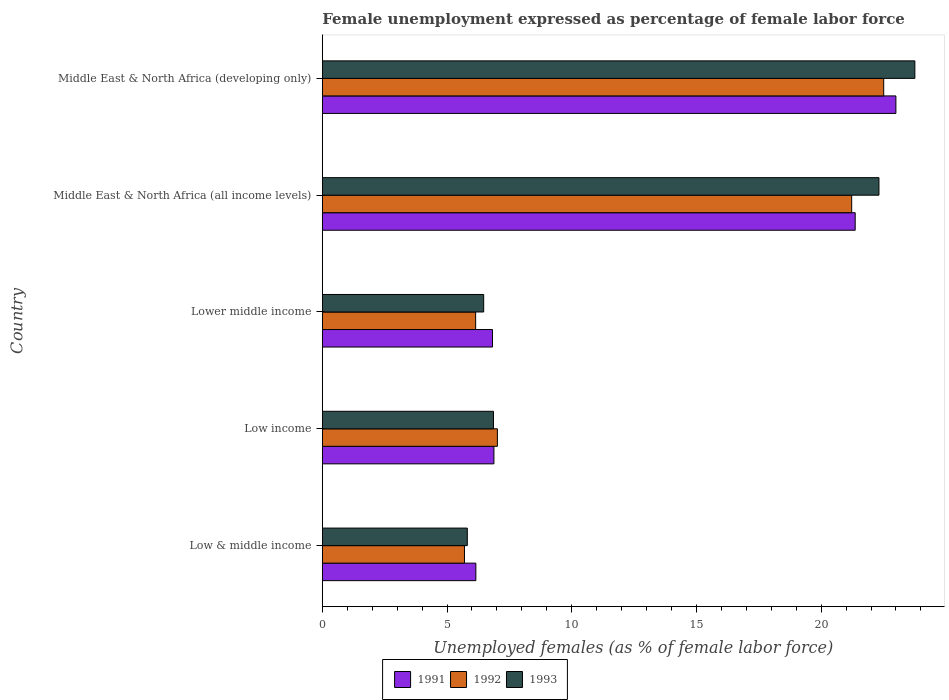How many different coloured bars are there?
Your answer should be very brief. 3. How many groups of bars are there?
Keep it short and to the point. 5. How many bars are there on the 1st tick from the top?
Your response must be concise. 3. How many bars are there on the 2nd tick from the bottom?
Give a very brief answer. 3. What is the label of the 3rd group of bars from the top?
Keep it short and to the point. Lower middle income. In how many cases, is the number of bars for a given country not equal to the number of legend labels?
Give a very brief answer. 0. What is the unemployment in females in in 1993 in Low & middle income?
Give a very brief answer. 5.81. Across all countries, what is the maximum unemployment in females in in 1993?
Make the answer very short. 23.76. Across all countries, what is the minimum unemployment in females in in 1992?
Your response must be concise. 5.7. In which country was the unemployment in females in in 1991 maximum?
Provide a succinct answer. Middle East & North Africa (developing only). What is the total unemployment in females in in 1991 in the graph?
Keep it short and to the point. 64.22. What is the difference between the unemployment in females in in 1992 in Lower middle income and that in Middle East & North Africa (all income levels)?
Offer a terse response. -15.08. What is the difference between the unemployment in females in in 1992 in Low & middle income and the unemployment in females in in 1991 in Low income?
Make the answer very short. -1.18. What is the average unemployment in females in in 1991 per country?
Keep it short and to the point. 12.84. What is the difference between the unemployment in females in in 1992 and unemployment in females in in 1993 in Middle East & North Africa (all income levels)?
Your response must be concise. -1.09. What is the ratio of the unemployment in females in in 1992 in Low & middle income to that in Middle East & North Africa (developing only)?
Make the answer very short. 0.25. Is the unemployment in females in in 1993 in Middle East & North Africa (all income levels) less than that in Middle East & North Africa (developing only)?
Make the answer very short. Yes. What is the difference between the highest and the second highest unemployment in females in in 1993?
Make the answer very short. 1.44. What is the difference between the highest and the lowest unemployment in females in in 1993?
Your answer should be very brief. 17.94. In how many countries, is the unemployment in females in in 1993 greater than the average unemployment in females in in 1993 taken over all countries?
Offer a very short reply. 2. What does the 2nd bar from the top in Low & middle income represents?
Offer a very short reply. 1992. How many bars are there?
Give a very brief answer. 15. How many countries are there in the graph?
Keep it short and to the point. 5. Are the values on the major ticks of X-axis written in scientific E-notation?
Give a very brief answer. No. Does the graph contain any zero values?
Offer a terse response. No. How many legend labels are there?
Keep it short and to the point. 3. How are the legend labels stacked?
Offer a very short reply. Horizontal. What is the title of the graph?
Make the answer very short. Female unemployment expressed as percentage of female labor force. Does "2009" appear as one of the legend labels in the graph?
Offer a very short reply. No. What is the label or title of the X-axis?
Offer a very short reply. Unemployed females (as % of female labor force). What is the Unemployed females (as % of female labor force) in 1991 in Low & middle income?
Give a very brief answer. 6.16. What is the Unemployed females (as % of female labor force) of 1992 in Low & middle income?
Give a very brief answer. 5.7. What is the Unemployed females (as % of female labor force) of 1993 in Low & middle income?
Provide a short and direct response. 5.81. What is the Unemployed females (as % of female labor force) in 1991 in Low income?
Give a very brief answer. 6.88. What is the Unemployed females (as % of female labor force) of 1992 in Low income?
Provide a succinct answer. 7.02. What is the Unemployed females (as % of female labor force) in 1993 in Low income?
Your answer should be very brief. 6.86. What is the Unemployed females (as % of female labor force) in 1991 in Lower middle income?
Provide a succinct answer. 6.82. What is the Unemployed females (as % of female labor force) in 1992 in Lower middle income?
Ensure brevity in your answer.  6.15. What is the Unemployed females (as % of female labor force) in 1993 in Lower middle income?
Keep it short and to the point. 6.47. What is the Unemployed females (as % of female labor force) in 1991 in Middle East & North Africa (all income levels)?
Provide a short and direct response. 21.36. What is the Unemployed females (as % of female labor force) in 1992 in Middle East & North Africa (all income levels)?
Offer a terse response. 21.22. What is the Unemployed females (as % of female labor force) in 1993 in Middle East & North Africa (all income levels)?
Make the answer very short. 22.32. What is the Unemployed females (as % of female labor force) in 1991 in Middle East & North Africa (developing only)?
Provide a short and direct response. 23. What is the Unemployed females (as % of female labor force) of 1992 in Middle East & North Africa (developing only)?
Your answer should be very brief. 22.51. What is the Unemployed females (as % of female labor force) in 1993 in Middle East & North Africa (developing only)?
Offer a terse response. 23.76. Across all countries, what is the maximum Unemployed females (as % of female labor force) in 1991?
Give a very brief answer. 23. Across all countries, what is the maximum Unemployed females (as % of female labor force) of 1992?
Your response must be concise. 22.51. Across all countries, what is the maximum Unemployed females (as % of female labor force) of 1993?
Your answer should be very brief. 23.76. Across all countries, what is the minimum Unemployed females (as % of female labor force) of 1991?
Provide a succinct answer. 6.16. Across all countries, what is the minimum Unemployed females (as % of female labor force) in 1992?
Your response must be concise. 5.7. Across all countries, what is the minimum Unemployed females (as % of female labor force) in 1993?
Keep it short and to the point. 5.81. What is the total Unemployed females (as % of female labor force) of 1991 in the graph?
Your response must be concise. 64.22. What is the total Unemployed females (as % of female labor force) in 1992 in the graph?
Give a very brief answer. 62.6. What is the total Unemployed females (as % of female labor force) in 1993 in the graph?
Offer a terse response. 65.22. What is the difference between the Unemployed females (as % of female labor force) in 1991 in Low & middle income and that in Low income?
Offer a very short reply. -0.72. What is the difference between the Unemployed females (as % of female labor force) in 1992 in Low & middle income and that in Low income?
Make the answer very short. -1.32. What is the difference between the Unemployed females (as % of female labor force) of 1993 in Low & middle income and that in Low income?
Keep it short and to the point. -1.05. What is the difference between the Unemployed females (as % of female labor force) in 1991 in Low & middle income and that in Lower middle income?
Provide a succinct answer. -0.67. What is the difference between the Unemployed females (as % of female labor force) of 1992 in Low & middle income and that in Lower middle income?
Your answer should be compact. -0.45. What is the difference between the Unemployed females (as % of female labor force) of 1993 in Low & middle income and that in Lower middle income?
Ensure brevity in your answer.  -0.66. What is the difference between the Unemployed females (as % of female labor force) of 1991 in Low & middle income and that in Middle East & North Africa (all income levels)?
Your answer should be very brief. -15.21. What is the difference between the Unemployed females (as % of female labor force) in 1992 in Low & middle income and that in Middle East & North Africa (all income levels)?
Ensure brevity in your answer.  -15.52. What is the difference between the Unemployed females (as % of female labor force) of 1993 in Low & middle income and that in Middle East & North Africa (all income levels)?
Your answer should be very brief. -16.5. What is the difference between the Unemployed females (as % of female labor force) of 1991 in Low & middle income and that in Middle East & North Africa (developing only)?
Offer a very short reply. -16.84. What is the difference between the Unemployed females (as % of female labor force) of 1992 in Low & middle income and that in Middle East & North Africa (developing only)?
Provide a short and direct response. -16.81. What is the difference between the Unemployed females (as % of female labor force) of 1993 in Low & middle income and that in Middle East & North Africa (developing only)?
Your answer should be very brief. -17.94. What is the difference between the Unemployed females (as % of female labor force) of 1991 in Low income and that in Lower middle income?
Provide a succinct answer. 0.06. What is the difference between the Unemployed females (as % of female labor force) of 1992 in Low income and that in Lower middle income?
Your answer should be very brief. 0.87. What is the difference between the Unemployed females (as % of female labor force) in 1993 in Low income and that in Lower middle income?
Offer a terse response. 0.39. What is the difference between the Unemployed females (as % of female labor force) in 1991 in Low income and that in Middle East & North Africa (all income levels)?
Provide a succinct answer. -14.48. What is the difference between the Unemployed females (as % of female labor force) in 1992 in Low income and that in Middle East & North Africa (all income levels)?
Keep it short and to the point. -14.2. What is the difference between the Unemployed females (as % of female labor force) of 1993 in Low income and that in Middle East & North Africa (all income levels)?
Your response must be concise. -15.45. What is the difference between the Unemployed females (as % of female labor force) of 1991 in Low income and that in Middle East & North Africa (developing only)?
Make the answer very short. -16.12. What is the difference between the Unemployed females (as % of female labor force) of 1992 in Low income and that in Middle East & North Africa (developing only)?
Ensure brevity in your answer.  -15.49. What is the difference between the Unemployed females (as % of female labor force) of 1993 in Low income and that in Middle East & North Africa (developing only)?
Make the answer very short. -16.89. What is the difference between the Unemployed females (as % of female labor force) of 1991 in Lower middle income and that in Middle East & North Africa (all income levels)?
Give a very brief answer. -14.54. What is the difference between the Unemployed females (as % of female labor force) of 1992 in Lower middle income and that in Middle East & North Africa (all income levels)?
Offer a terse response. -15.08. What is the difference between the Unemployed females (as % of female labor force) of 1993 in Lower middle income and that in Middle East & North Africa (all income levels)?
Offer a terse response. -15.85. What is the difference between the Unemployed females (as % of female labor force) in 1991 in Lower middle income and that in Middle East & North Africa (developing only)?
Ensure brevity in your answer.  -16.17. What is the difference between the Unemployed females (as % of female labor force) of 1992 in Lower middle income and that in Middle East & North Africa (developing only)?
Offer a terse response. -16.36. What is the difference between the Unemployed females (as % of female labor force) of 1993 in Lower middle income and that in Middle East & North Africa (developing only)?
Ensure brevity in your answer.  -17.29. What is the difference between the Unemployed females (as % of female labor force) in 1991 in Middle East & North Africa (all income levels) and that in Middle East & North Africa (developing only)?
Keep it short and to the point. -1.63. What is the difference between the Unemployed females (as % of female labor force) of 1992 in Middle East & North Africa (all income levels) and that in Middle East & North Africa (developing only)?
Give a very brief answer. -1.28. What is the difference between the Unemployed females (as % of female labor force) of 1993 in Middle East & North Africa (all income levels) and that in Middle East & North Africa (developing only)?
Ensure brevity in your answer.  -1.44. What is the difference between the Unemployed females (as % of female labor force) in 1991 in Low & middle income and the Unemployed females (as % of female labor force) in 1992 in Low income?
Give a very brief answer. -0.86. What is the difference between the Unemployed females (as % of female labor force) of 1991 in Low & middle income and the Unemployed females (as % of female labor force) of 1993 in Low income?
Provide a succinct answer. -0.71. What is the difference between the Unemployed females (as % of female labor force) in 1992 in Low & middle income and the Unemployed females (as % of female labor force) in 1993 in Low income?
Provide a succinct answer. -1.16. What is the difference between the Unemployed females (as % of female labor force) of 1991 in Low & middle income and the Unemployed females (as % of female labor force) of 1992 in Lower middle income?
Offer a very short reply. 0.01. What is the difference between the Unemployed females (as % of female labor force) of 1991 in Low & middle income and the Unemployed females (as % of female labor force) of 1993 in Lower middle income?
Your answer should be very brief. -0.31. What is the difference between the Unemployed females (as % of female labor force) in 1992 in Low & middle income and the Unemployed females (as % of female labor force) in 1993 in Lower middle income?
Offer a very short reply. -0.77. What is the difference between the Unemployed females (as % of female labor force) of 1991 in Low & middle income and the Unemployed females (as % of female labor force) of 1992 in Middle East & North Africa (all income levels)?
Your response must be concise. -15.07. What is the difference between the Unemployed females (as % of female labor force) of 1991 in Low & middle income and the Unemployed females (as % of female labor force) of 1993 in Middle East & North Africa (all income levels)?
Ensure brevity in your answer.  -16.16. What is the difference between the Unemployed females (as % of female labor force) of 1992 in Low & middle income and the Unemployed females (as % of female labor force) of 1993 in Middle East & North Africa (all income levels)?
Give a very brief answer. -16.62. What is the difference between the Unemployed females (as % of female labor force) in 1991 in Low & middle income and the Unemployed females (as % of female labor force) in 1992 in Middle East & North Africa (developing only)?
Your answer should be compact. -16.35. What is the difference between the Unemployed females (as % of female labor force) of 1991 in Low & middle income and the Unemployed females (as % of female labor force) of 1993 in Middle East & North Africa (developing only)?
Your response must be concise. -17.6. What is the difference between the Unemployed females (as % of female labor force) in 1992 in Low & middle income and the Unemployed females (as % of female labor force) in 1993 in Middle East & North Africa (developing only)?
Make the answer very short. -18.06. What is the difference between the Unemployed females (as % of female labor force) in 1991 in Low income and the Unemployed females (as % of female labor force) in 1992 in Lower middle income?
Your response must be concise. 0.73. What is the difference between the Unemployed females (as % of female labor force) of 1991 in Low income and the Unemployed females (as % of female labor force) of 1993 in Lower middle income?
Your answer should be compact. 0.41. What is the difference between the Unemployed females (as % of female labor force) in 1992 in Low income and the Unemployed females (as % of female labor force) in 1993 in Lower middle income?
Offer a terse response. 0.55. What is the difference between the Unemployed females (as % of female labor force) in 1991 in Low income and the Unemployed females (as % of female labor force) in 1992 in Middle East & North Africa (all income levels)?
Make the answer very short. -14.34. What is the difference between the Unemployed females (as % of female labor force) of 1991 in Low income and the Unemployed females (as % of female labor force) of 1993 in Middle East & North Africa (all income levels)?
Ensure brevity in your answer.  -15.44. What is the difference between the Unemployed females (as % of female labor force) of 1992 in Low income and the Unemployed females (as % of female labor force) of 1993 in Middle East & North Africa (all income levels)?
Ensure brevity in your answer.  -15.3. What is the difference between the Unemployed females (as % of female labor force) in 1991 in Low income and the Unemployed females (as % of female labor force) in 1992 in Middle East & North Africa (developing only)?
Provide a succinct answer. -15.63. What is the difference between the Unemployed females (as % of female labor force) in 1991 in Low income and the Unemployed females (as % of female labor force) in 1993 in Middle East & North Africa (developing only)?
Give a very brief answer. -16.88. What is the difference between the Unemployed females (as % of female labor force) of 1992 in Low income and the Unemployed females (as % of female labor force) of 1993 in Middle East & North Africa (developing only)?
Give a very brief answer. -16.74. What is the difference between the Unemployed females (as % of female labor force) in 1991 in Lower middle income and the Unemployed females (as % of female labor force) in 1992 in Middle East & North Africa (all income levels)?
Offer a very short reply. -14.4. What is the difference between the Unemployed females (as % of female labor force) in 1991 in Lower middle income and the Unemployed females (as % of female labor force) in 1993 in Middle East & North Africa (all income levels)?
Keep it short and to the point. -15.49. What is the difference between the Unemployed females (as % of female labor force) in 1992 in Lower middle income and the Unemployed females (as % of female labor force) in 1993 in Middle East & North Africa (all income levels)?
Give a very brief answer. -16.17. What is the difference between the Unemployed females (as % of female labor force) in 1991 in Lower middle income and the Unemployed females (as % of female labor force) in 1992 in Middle East & North Africa (developing only)?
Provide a succinct answer. -15.69. What is the difference between the Unemployed females (as % of female labor force) in 1991 in Lower middle income and the Unemployed females (as % of female labor force) in 1993 in Middle East & North Africa (developing only)?
Keep it short and to the point. -16.93. What is the difference between the Unemployed females (as % of female labor force) of 1992 in Lower middle income and the Unemployed females (as % of female labor force) of 1993 in Middle East & North Africa (developing only)?
Offer a very short reply. -17.61. What is the difference between the Unemployed females (as % of female labor force) of 1991 in Middle East & North Africa (all income levels) and the Unemployed females (as % of female labor force) of 1992 in Middle East & North Africa (developing only)?
Provide a succinct answer. -1.14. What is the difference between the Unemployed females (as % of female labor force) of 1991 in Middle East & North Africa (all income levels) and the Unemployed females (as % of female labor force) of 1993 in Middle East & North Africa (developing only)?
Your answer should be very brief. -2.39. What is the difference between the Unemployed females (as % of female labor force) of 1992 in Middle East & North Africa (all income levels) and the Unemployed females (as % of female labor force) of 1993 in Middle East & North Africa (developing only)?
Your response must be concise. -2.53. What is the average Unemployed females (as % of female labor force) in 1991 per country?
Your answer should be very brief. 12.84. What is the average Unemployed females (as % of female labor force) of 1992 per country?
Offer a very short reply. 12.52. What is the average Unemployed females (as % of female labor force) of 1993 per country?
Offer a very short reply. 13.04. What is the difference between the Unemployed females (as % of female labor force) in 1991 and Unemployed females (as % of female labor force) in 1992 in Low & middle income?
Your response must be concise. 0.46. What is the difference between the Unemployed females (as % of female labor force) in 1991 and Unemployed females (as % of female labor force) in 1993 in Low & middle income?
Give a very brief answer. 0.34. What is the difference between the Unemployed females (as % of female labor force) in 1992 and Unemployed females (as % of female labor force) in 1993 in Low & middle income?
Your answer should be very brief. -0.11. What is the difference between the Unemployed females (as % of female labor force) in 1991 and Unemployed females (as % of female labor force) in 1992 in Low income?
Ensure brevity in your answer.  -0.14. What is the difference between the Unemployed females (as % of female labor force) of 1991 and Unemployed females (as % of female labor force) of 1993 in Low income?
Ensure brevity in your answer.  0.02. What is the difference between the Unemployed females (as % of female labor force) in 1992 and Unemployed females (as % of female labor force) in 1993 in Low income?
Keep it short and to the point. 0.16. What is the difference between the Unemployed females (as % of female labor force) of 1991 and Unemployed females (as % of female labor force) of 1992 in Lower middle income?
Keep it short and to the point. 0.68. What is the difference between the Unemployed females (as % of female labor force) of 1991 and Unemployed females (as % of female labor force) of 1993 in Lower middle income?
Provide a short and direct response. 0.35. What is the difference between the Unemployed females (as % of female labor force) in 1992 and Unemployed females (as % of female labor force) in 1993 in Lower middle income?
Provide a succinct answer. -0.32. What is the difference between the Unemployed females (as % of female labor force) in 1991 and Unemployed females (as % of female labor force) in 1992 in Middle East & North Africa (all income levels)?
Provide a short and direct response. 0.14. What is the difference between the Unemployed females (as % of female labor force) in 1991 and Unemployed females (as % of female labor force) in 1993 in Middle East & North Africa (all income levels)?
Your answer should be very brief. -0.95. What is the difference between the Unemployed females (as % of female labor force) of 1992 and Unemployed females (as % of female labor force) of 1993 in Middle East & North Africa (all income levels)?
Give a very brief answer. -1.09. What is the difference between the Unemployed females (as % of female labor force) in 1991 and Unemployed females (as % of female labor force) in 1992 in Middle East & North Africa (developing only)?
Make the answer very short. 0.49. What is the difference between the Unemployed females (as % of female labor force) in 1991 and Unemployed females (as % of female labor force) in 1993 in Middle East & North Africa (developing only)?
Provide a succinct answer. -0.76. What is the difference between the Unemployed females (as % of female labor force) of 1992 and Unemployed females (as % of female labor force) of 1993 in Middle East & North Africa (developing only)?
Ensure brevity in your answer.  -1.25. What is the ratio of the Unemployed females (as % of female labor force) of 1991 in Low & middle income to that in Low income?
Offer a terse response. 0.89. What is the ratio of the Unemployed females (as % of female labor force) in 1992 in Low & middle income to that in Low income?
Give a very brief answer. 0.81. What is the ratio of the Unemployed females (as % of female labor force) of 1993 in Low & middle income to that in Low income?
Make the answer very short. 0.85. What is the ratio of the Unemployed females (as % of female labor force) in 1991 in Low & middle income to that in Lower middle income?
Give a very brief answer. 0.9. What is the ratio of the Unemployed females (as % of female labor force) in 1992 in Low & middle income to that in Lower middle income?
Your response must be concise. 0.93. What is the ratio of the Unemployed females (as % of female labor force) in 1993 in Low & middle income to that in Lower middle income?
Provide a short and direct response. 0.9. What is the ratio of the Unemployed females (as % of female labor force) in 1991 in Low & middle income to that in Middle East & North Africa (all income levels)?
Ensure brevity in your answer.  0.29. What is the ratio of the Unemployed females (as % of female labor force) in 1992 in Low & middle income to that in Middle East & North Africa (all income levels)?
Ensure brevity in your answer.  0.27. What is the ratio of the Unemployed females (as % of female labor force) in 1993 in Low & middle income to that in Middle East & North Africa (all income levels)?
Your response must be concise. 0.26. What is the ratio of the Unemployed females (as % of female labor force) of 1991 in Low & middle income to that in Middle East & North Africa (developing only)?
Keep it short and to the point. 0.27. What is the ratio of the Unemployed females (as % of female labor force) in 1992 in Low & middle income to that in Middle East & North Africa (developing only)?
Ensure brevity in your answer.  0.25. What is the ratio of the Unemployed females (as % of female labor force) in 1993 in Low & middle income to that in Middle East & North Africa (developing only)?
Make the answer very short. 0.24. What is the ratio of the Unemployed females (as % of female labor force) in 1991 in Low income to that in Lower middle income?
Make the answer very short. 1.01. What is the ratio of the Unemployed females (as % of female labor force) in 1992 in Low income to that in Lower middle income?
Offer a terse response. 1.14. What is the ratio of the Unemployed females (as % of female labor force) in 1993 in Low income to that in Lower middle income?
Keep it short and to the point. 1.06. What is the ratio of the Unemployed females (as % of female labor force) of 1991 in Low income to that in Middle East & North Africa (all income levels)?
Offer a very short reply. 0.32. What is the ratio of the Unemployed females (as % of female labor force) in 1992 in Low income to that in Middle East & North Africa (all income levels)?
Offer a very short reply. 0.33. What is the ratio of the Unemployed females (as % of female labor force) in 1993 in Low income to that in Middle East & North Africa (all income levels)?
Offer a very short reply. 0.31. What is the ratio of the Unemployed females (as % of female labor force) of 1991 in Low income to that in Middle East & North Africa (developing only)?
Offer a terse response. 0.3. What is the ratio of the Unemployed females (as % of female labor force) in 1992 in Low income to that in Middle East & North Africa (developing only)?
Provide a short and direct response. 0.31. What is the ratio of the Unemployed females (as % of female labor force) in 1993 in Low income to that in Middle East & North Africa (developing only)?
Ensure brevity in your answer.  0.29. What is the ratio of the Unemployed females (as % of female labor force) in 1991 in Lower middle income to that in Middle East & North Africa (all income levels)?
Provide a short and direct response. 0.32. What is the ratio of the Unemployed females (as % of female labor force) in 1992 in Lower middle income to that in Middle East & North Africa (all income levels)?
Offer a very short reply. 0.29. What is the ratio of the Unemployed females (as % of female labor force) of 1993 in Lower middle income to that in Middle East & North Africa (all income levels)?
Your response must be concise. 0.29. What is the ratio of the Unemployed females (as % of female labor force) of 1991 in Lower middle income to that in Middle East & North Africa (developing only)?
Your answer should be compact. 0.3. What is the ratio of the Unemployed females (as % of female labor force) in 1992 in Lower middle income to that in Middle East & North Africa (developing only)?
Make the answer very short. 0.27. What is the ratio of the Unemployed females (as % of female labor force) in 1993 in Lower middle income to that in Middle East & North Africa (developing only)?
Provide a short and direct response. 0.27. What is the ratio of the Unemployed females (as % of female labor force) in 1991 in Middle East & North Africa (all income levels) to that in Middle East & North Africa (developing only)?
Your answer should be compact. 0.93. What is the ratio of the Unemployed females (as % of female labor force) of 1992 in Middle East & North Africa (all income levels) to that in Middle East & North Africa (developing only)?
Make the answer very short. 0.94. What is the ratio of the Unemployed females (as % of female labor force) of 1993 in Middle East & North Africa (all income levels) to that in Middle East & North Africa (developing only)?
Provide a short and direct response. 0.94. What is the difference between the highest and the second highest Unemployed females (as % of female labor force) in 1991?
Keep it short and to the point. 1.63. What is the difference between the highest and the second highest Unemployed females (as % of female labor force) in 1992?
Offer a terse response. 1.28. What is the difference between the highest and the second highest Unemployed females (as % of female labor force) of 1993?
Provide a short and direct response. 1.44. What is the difference between the highest and the lowest Unemployed females (as % of female labor force) of 1991?
Your response must be concise. 16.84. What is the difference between the highest and the lowest Unemployed females (as % of female labor force) in 1992?
Provide a succinct answer. 16.81. What is the difference between the highest and the lowest Unemployed females (as % of female labor force) in 1993?
Your answer should be compact. 17.94. 